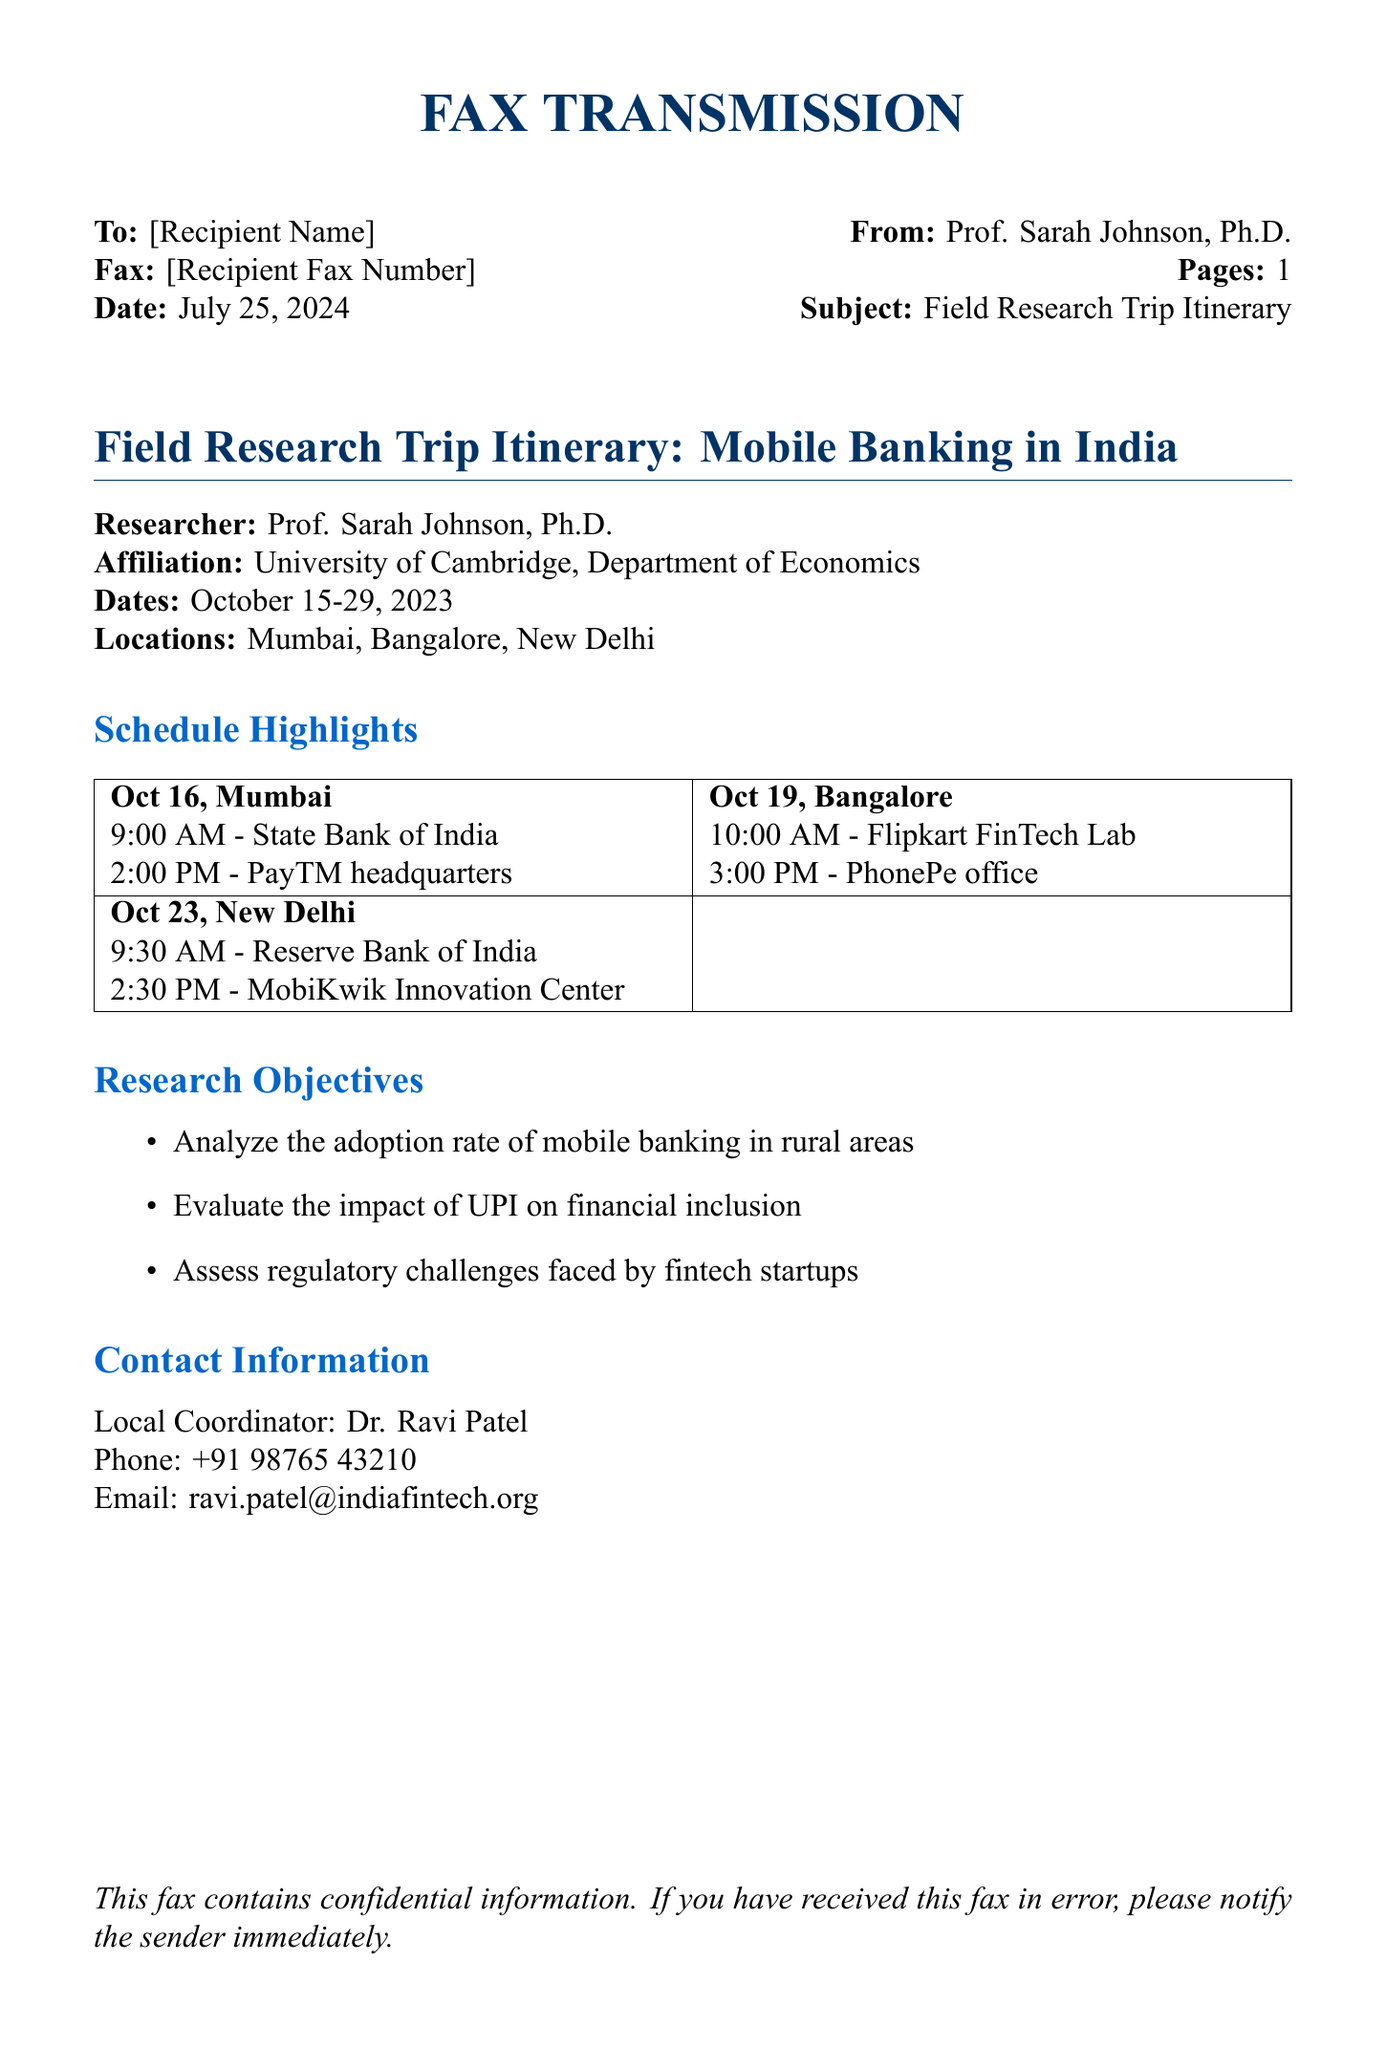What is the name of the researcher? The document specifies the researcher as Prof. Sarah Johnson, Ph.D.
Answer: Prof. Sarah Johnson, Ph.D What is the affiliation of the researcher? The researcher is affiliated with the University of Cambridge, Department of Economics.
Answer: University of Cambridge, Department of Economics What are the dates of the field research trip? The document outlines the trip dates as October 15-29, 2023.
Answer: October 15-29, 2023 Where is the Reserve Bank of India located in the schedule? The Reserve Bank of India is scheduled for October 23 in New Delhi.
Answer: October 23, New Delhi What are the research objectives focused on? The document lists three key objectives, including analyzing adoption rates of mobile banking, evaluating UPI's impact, and assessing fintech regulatory challenges.
Answer: Analyze the adoption rate of mobile banking in rural areas, evaluate the impact of UPI on financial inclusion, assess regulatory challenges faced by fintech startups Who is the local coordinator for the trip? The document identifies the local coordinator as Dr. Ravi Patel.
Answer: Dr. Ravi Patel What time is the meeting with PayTM headquarters? The scheduled meeting with PayTM headquarters is at 2:00 PM on October 16.
Answer: 2:00 PM What city will the researcher visit on October 19? The document indicates that the researcher will visit Bangalore on October 19.
Answer: Bangalore How many locations are mentioned in the itinerary? The itinerary lists three locations: Mumbai, Bangalore, and New Delhi.
Answer: Three locations 